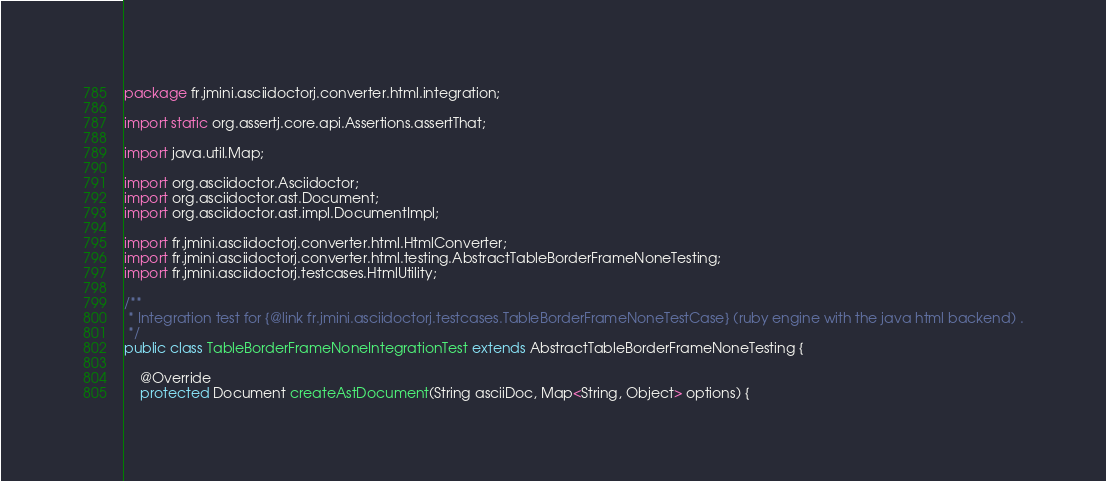<code> <loc_0><loc_0><loc_500><loc_500><_Java_>package fr.jmini.asciidoctorj.converter.html.integration;

import static org.assertj.core.api.Assertions.assertThat;

import java.util.Map;

import org.asciidoctor.Asciidoctor;
import org.asciidoctor.ast.Document;
import org.asciidoctor.ast.impl.DocumentImpl;

import fr.jmini.asciidoctorj.converter.html.HtmlConverter;
import fr.jmini.asciidoctorj.converter.html.testing.AbstractTableBorderFrameNoneTesting;
import fr.jmini.asciidoctorj.testcases.HtmlUtility;

/**
 * Integration test for {@link fr.jmini.asciidoctorj.testcases.TableBorderFrameNoneTestCase} (ruby engine with the java html backend) .
 */
public class TableBorderFrameNoneIntegrationTest extends AbstractTableBorderFrameNoneTesting {

    @Override
    protected Document createAstDocument(String asciiDoc, Map<String, Object> options) {</code> 